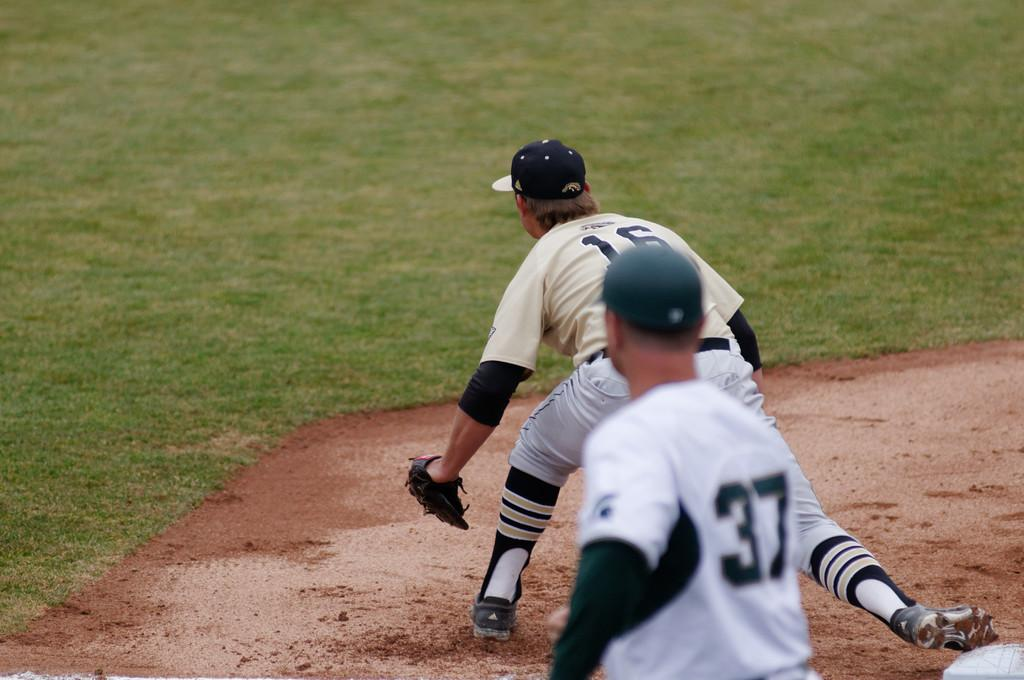<image>
Share a concise interpretation of the image provided. a player with the number 16 stretching out 